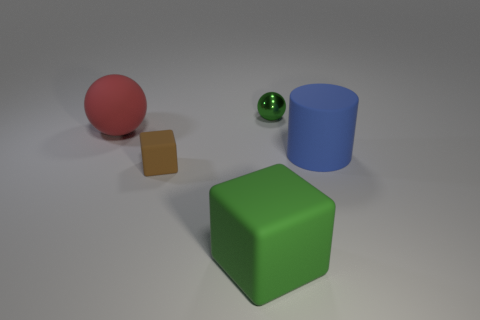What number of big spheres are the same material as the big cylinder?
Provide a succinct answer. 1. What size is the sphere that is on the right side of the large thing behind the large thing to the right of the large green thing?
Make the answer very short. Small. What number of large red objects are left of the blue object?
Ensure brevity in your answer.  1. Is the number of big purple cylinders greater than the number of matte balls?
Give a very brief answer. No. What size is the object that is the same color as the metallic sphere?
Ensure brevity in your answer.  Large. How big is the thing that is behind the small brown cube and on the left side of the large green rubber thing?
Ensure brevity in your answer.  Large. The big thing that is to the right of the green thing that is in front of the object that is on the right side of the tiny green thing is made of what material?
Offer a very short reply. Rubber. There is a big object that is the same color as the tiny sphere; what is it made of?
Provide a short and direct response. Rubber. There is a sphere to the right of the large red ball; does it have the same color as the large rubber object on the right side of the small green metallic ball?
Ensure brevity in your answer.  No. There is a green thing behind the large object that is to the left of the small thing in front of the large sphere; what shape is it?
Provide a succinct answer. Sphere. 